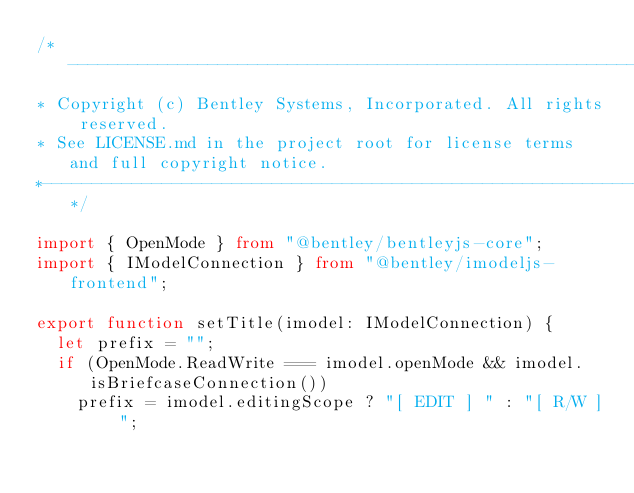<code> <loc_0><loc_0><loc_500><loc_500><_TypeScript_>/*---------------------------------------------------------------------------------------------
* Copyright (c) Bentley Systems, Incorporated. All rights reserved.
* See LICENSE.md in the project root for license terms and full copyright notice.
*--------------------------------------------------------------------------------------------*/

import { OpenMode } from "@bentley/bentleyjs-core";
import { IModelConnection } from "@bentley/imodeljs-frontend";

export function setTitle(imodel: IModelConnection) {
  let prefix = "";
  if (OpenMode.ReadWrite === imodel.openMode && imodel.isBriefcaseConnection())
    prefix = imodel.editingScope ? "[ EDIT ] " : "[ R/W ] ";
</code> 